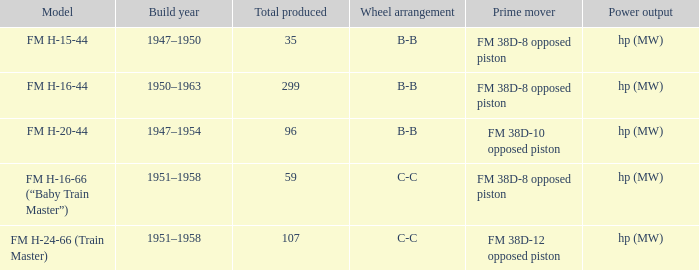What is the minimum total yield generated by an fm h-15-44 model? 35.0. 